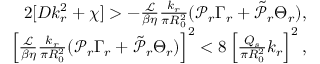Convert formula to latex. <formula><loc_0><loc_0><loc_500><loc_500>\begin{array} { r } { 2 [ D k _ { r } ^ { 2 } + \chi ] > - \frac { \mathcal { L } } { \beta \eta } \frac { k _ { r } } { \pi R _ { 0 } ^ { 2 } } ( \mathcal { P } _ { r } \Gamma _ { r } + \tilde { \mathcal { P } } _ { r } \Theta _ { r } ) , } \\ { \left [ \frac { \mathcal { L } } { \beta \eta } \frac { k _ { r } } { \pi R _ { 0 } ^ { 2 } } ( \mathcal { P } _ { r } \Gamma _ { r } + \tilde { \mathcal { P } } _ { r } \Theta _ { r } ) \right ] ^ { 2 } < 8 \left [ \frac { Q _ { s } } { \pi R _ { 0 } ^ { 2 } } k _ { r } \right ] ^ { 2 } , } \end{array}</formula> 